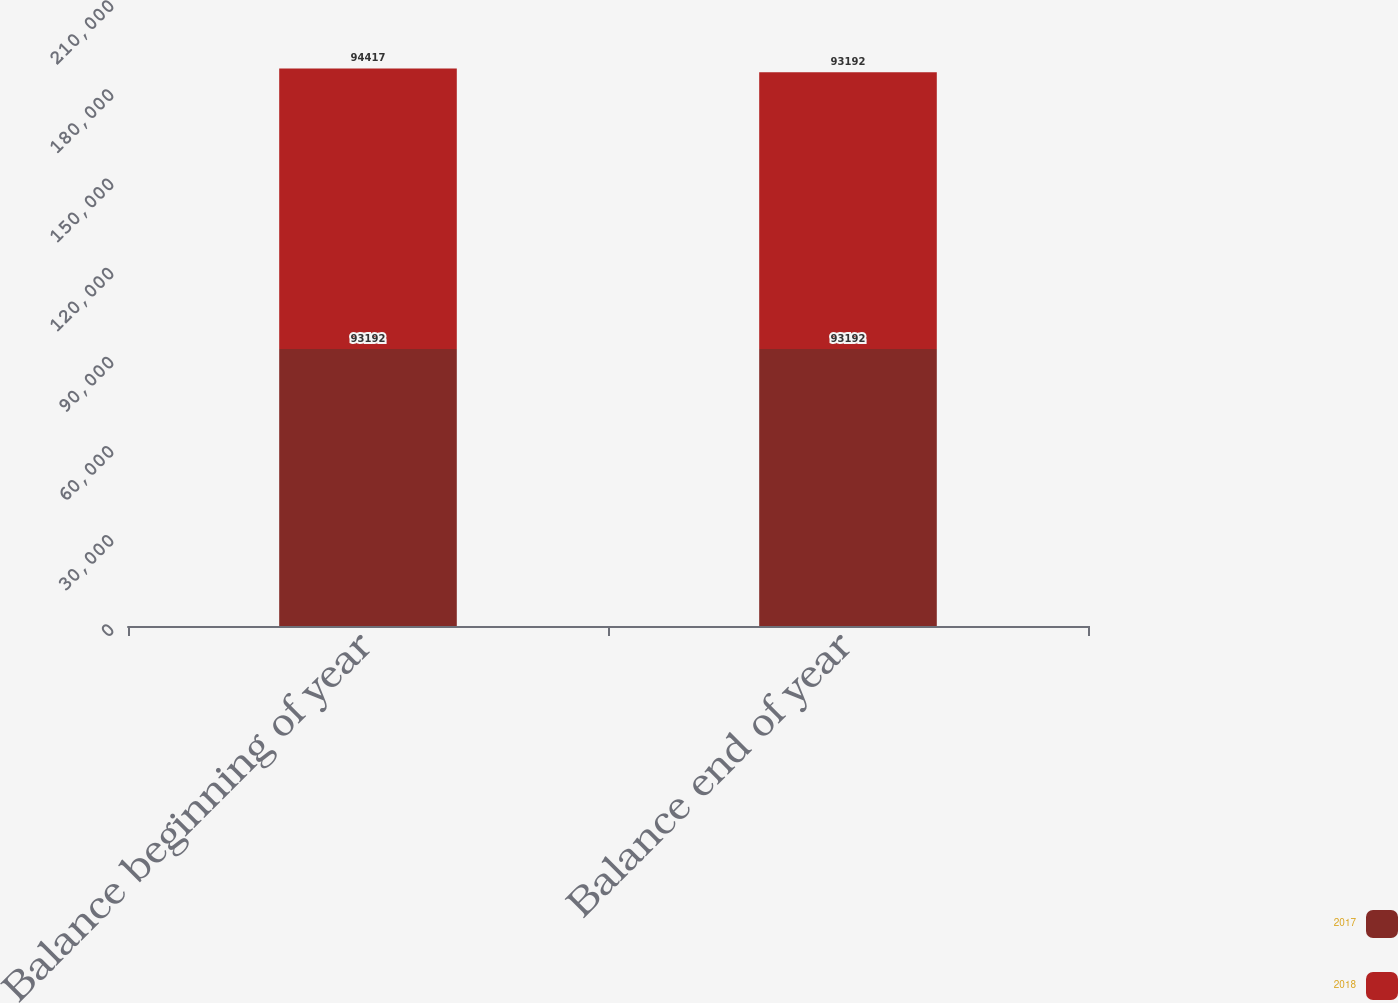Convert chart. <chart><loc_0><loc_0><loc_500><loc_500><stacked_bar_chart><ecel><fcel>Balance beginning of year<fcel>Balance end of year<nl><fcel>2017<fcel>93192<fcel>93192<nl><fcel>2018<fcel>94417<fcel>93192<nl></chart> 